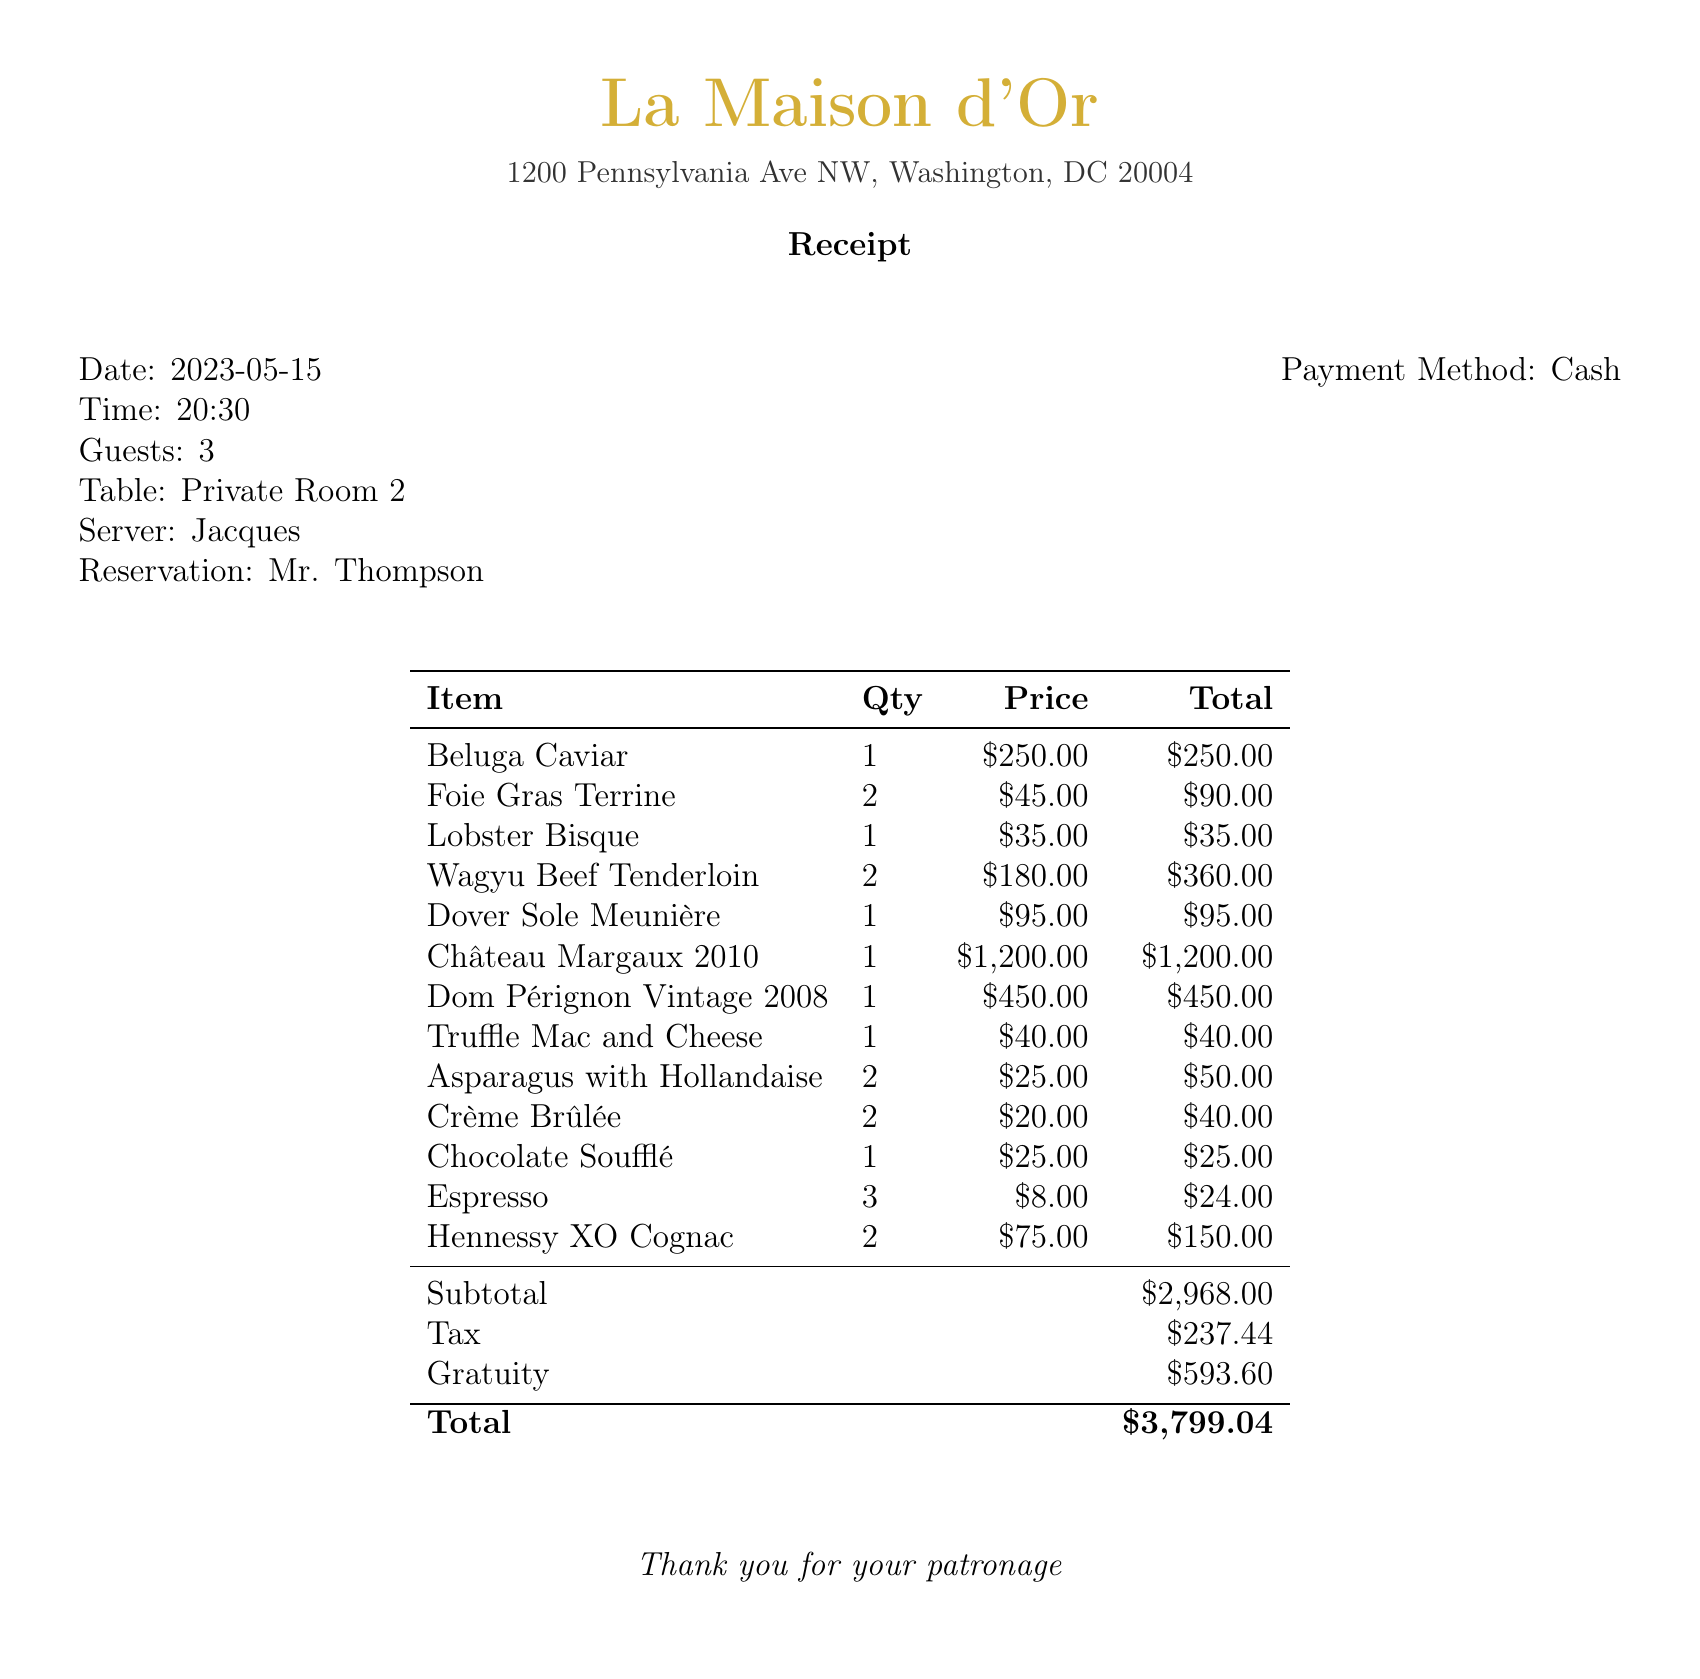what is the name of the restaurant? The document specifies the restaurant's name as the header, which is "La Maison d'Or".
Answer: La Maison d'Or what is the total amount of the bill? The total amount is presented at the bottom of the receipt, which sums up all costs including tax and gratuity.
Answer: $3,799.04 how many guests were present at the meeting? The receipt indicates the number of guests directly after the date and time information.
Answer: 3 who made the reservation? The document lists the reservation name at the end of the table information, which is important for identifying the party.
Answer: Mr. Thompson what was the quantity of Hennessy XO Cognac ordered? The itemized list explicitly shows the quantity for Hennessy XO Cognac.
Answer: 2 what item had the highest price? By comparing all item prices, the document reveals that Château Margaux 2010 is the most expensive item.
Answer: Château Margaux 2010 what was the gratuity amount? The gratuity amount is clearly marked within the summary section of the receipt, indicating the service provided.
Answer: $593.60 which server attended to the table? The server's name is listed in the table information provided at the top of the receipt.
Answer: Jacques what was the date of the meeting? The date is mentioned prominently at the top of the receipt.
Answer: 2023-05-15 